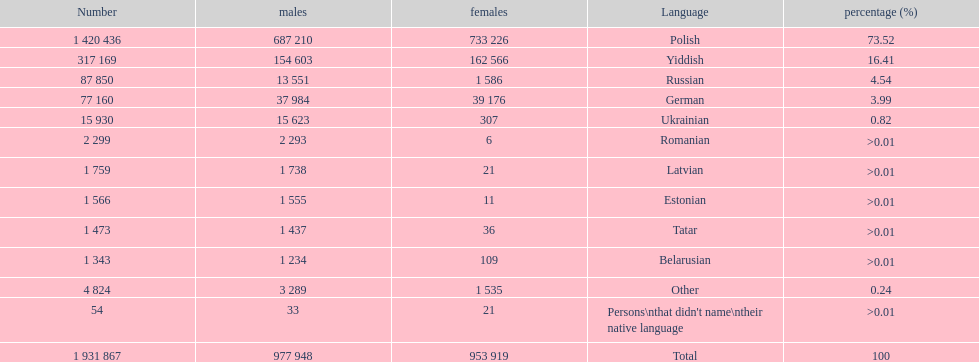Which language had the least female speakers? Romanian. 